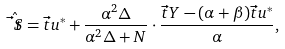Convert formula to latex. <formula><loc_0><loc_0><loc_500><loc_500>\hat { \vec { t } { S } } = \vec { t } { u } ^ { * } + \frac { \alpha ^ { 2 } \Delta } { \alpha ^ { 2 } \Delta + N } \cdot \frac { \vec { t } { Y } - ( \alpha + \beta ) \vec { t } { u } ^ { * } } { \alpha } ,</formula> 